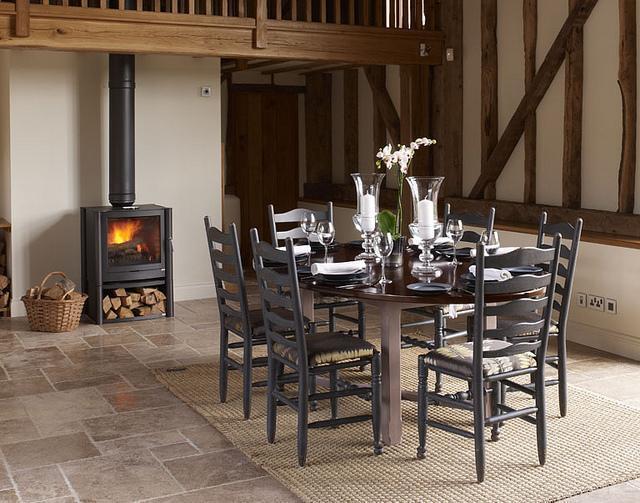What plants help heat this space?
From the following four choices, select the correct answer to address the question.
Options: Trees, cotton, flax, bamboo. Trees. 